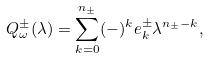Convert formula to latex. <formula><loc_0><loc_0><loc_500><loc_500>Q _ { \omega } ^ { \pm } ( \lambda ) = \sum _ { k = 0 } ^ { n _ { \pm } } ( - ) ^ { k } e _ { k } ^ { \pm } \lambda ^ { n _ { \pm } - k } ,</formula> 